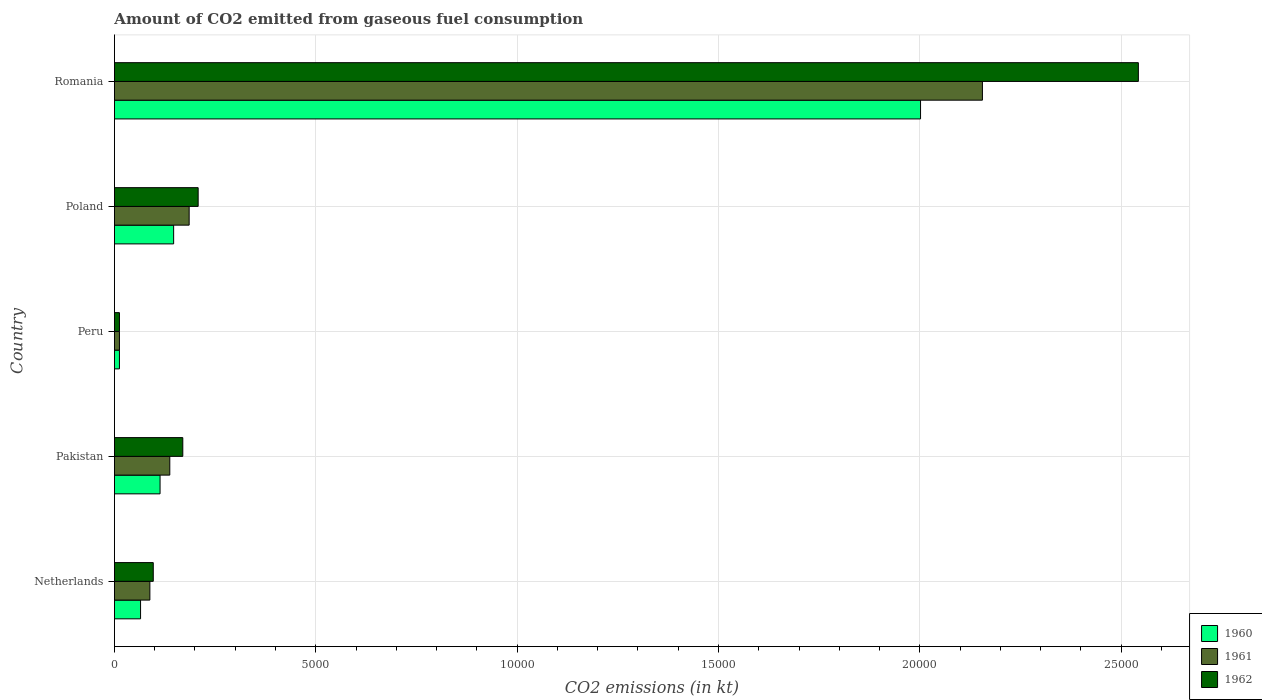How many different coloured bars are there?
Provide a short and direct response. 3. How many bars are there on the 4th tick from the top?
Your response must be concise. 3. What is the amount of CO2 emitted in 1961 in Pakistan?
Ensure brevity in your answer.  1375.12. Across all countries, what is the maximum amount of CO2 emitted in 1961?
Provide a short and direct response. 2.16e+04. Across all countries, what is the minimum amount of CO2 emitted in 1962?
Offer a very short reply. 124.68. In which country was the amount of CO2 emitted in 1962 maximum?
Give a very brief answer. Romania. What is the total amount of CO2 emitted in 1962 in the graph?
Ensure brevity in your answer.  3.03e+04. What is the difference between the amount of CO2 emitted in 1961 in Peru and that in Romania?
Give a very brief answer. -2.14e+04. What is the difference between the amount of CO2 emitted in 1960 in Romania and the amount of CO2 emitted in 1961 in Peru?
Provide a short and direct response. 1.99e+04. What is the average amount of CO2 emitted in 1961 per country?
Provide a succinct answer. 5158. What is the difference between the amount of CO2 emitted in 1962 and amount of CO2 emitted in 1961 in Netherlands?
Offer a very short reply. 84.34. What is the ratio of the amount of CO2 emitted in 1962 in Peru to that in Romania?
Provide a succinct answer. 0. What is the difference between the highest and the second highest amount of CO2 emitted in 1962?
Provide a short and direct response. 2.33e+04. What is the difference between the highest and the lowest amount of CO2 emitted in 1960?
Make the answer very short. 1.99e+04. What does the 1st bar from the top in Poland represents?
Your answer should be compact. 1962. Is it the case that in every country, the sum of the amount of CO2 emitted in 1961 and amount of CO2 emitted in 1962 is greater than the amount of CO2 emitted in 1960?
Offer a very short reply. Yes. How many bars are there?
Your answer should be compact. 15. How many countries are there in the graph?
Ensure brevity in your answer.  5. What is the difference between two consecutive major ticks on the X-axis?
Your response must be concise. 5000. Does the graph contain any zero values?
Your answer should be compact. No. Does the graph contain grids?
Your answer should be very brief. Yes. How many legend labels are there?
Offer a terse response. 3. What is the title of the graph?
Offer a terse response. Amount of CO2 emitted from gaseous fuel consumption. What is the label or title of the X-axis?
Offer a terse response. CO2 emissions (in kt). What is the label or title of the Y-axis?
Offer a very short reply. Country. What is the CO2 emissions (in kt) of 1960 in Netherlands?
Offer a terse response. 649.06. What is the CO2 emissions (in kt) in 1961 in Netherlands?
Provide a short and direct response. 880.08. What is the CO2 emissions (in kt) in 1962 in Netherlands?
Your answer should be very brief. 964.42. What is the CO2 emissions (in kt) in 1960 in Pakistan?
Offer a very short reply. 1133.1. What is the CO2 emissions (in kt) of 1961 in Pakistan?
Provide a short and direct response. 1375.12. What is the CO2 emissions (in kt) in 1962 in Pakistan?
Provide a short and direct response. 1697.82. What is the CO2 emissions (in kt) in 1960 in Peru?
Provide a succinct answer. 124.68. What is the CO2 emissions (in kt) of 1961 in Peru?
Keep it short and to the point. 124.68. What is the CO2 emissions (in kt) of 1962 in Peru?
Provide a succinct answer. 124.68. What is the CO2 emissions (in kt) in 1960 in Poland?
Give a very brief answer. 1470.47. What is the CO2 emissions (in kt) in 1961 in Poland?
Offer a terse response. 1855.5. What is the CO2 emissions (in kt) in 1962 in Poland?
Offer a very short reply. 2079.19. What is the CO2 emissions (in kt) in 1960 in Romania?
Provide a succinct answer. 2.00e+04. What is the CO2 emissions (in kt) in 1961 in Romania?
Offer a very short reply. 2.16e+04. What is the CO2 emissions (in kt) of 1962 in Romania?
Give a very brief answer. 2.54e+04. Across all countries, what is the maximum CO2 emissions (in kt) of 1960?
Give a very brief answer. 2.00e+04. Across all countries, what is the maximum CO2 emissions (in kt) in 1961?
Offer a very short reply. 2.16e+04. Across all countries, what is the maximum CO2 emissions (in kt) of 1962?
Give a very brief answer. 2.54e+04. Across all countries, what is the minimum CO2 emissions (in kt) in 1960?
Provide a succinct answer. 124.68. Across all countries, what is the minimum CO2 emissions (in kt) of 1961?
Make the answer very short. 124.68. Across all countries, what is the minimum CO2 emissions (in kt) in 1962?
Make the answer very short. 124.68. What is the total CO2 emissions (in kt) of 1960 in the graph?
Your answer should be compact. 2.34e+04. What is the total CO2 emissions (in kt) in 1961 in the graph?
Provide a short and direct response. 2.58e+04. What is the total CO2 emissions (in kt) in 1962 in the graph?
Keep it short and to the point. 3.03e+04. What is the difference between the CO2 emissions (in kt) in 1960 in Netherlands and that in Pakistan?
Ensure brevity in your answer.  -484.04. What is the difference between the CO2 emissions (in kt) of 1961 in Netherlands and that in Pakistan?
Provide a short and direct response. -495.05. What is the difference between the CO2 emissions (in kt) in 1962 in Netherlands and that in Pakistan?
Offer a terse response. -733.4. What is the difference between the CO2 emissions (in kt) of 1960 in Netherlands and that in Peru?
Your answer should be compact. 524.38. What is the difference between the CO2 emissions (in kt) of 1961 in Netherlands and that in Peru?
Make the answer very short. 755.4. What is the difference between the CO2 emissions (in kt) of 1962 in Netherlands and that in Peru?
Your response must be concise. 839.74. What is the difference between the CO2 emissions (in kt) of 1960 in Netherlands and that in Poland?
Provide a succinct answer. -821.41. What is the difference between the CO2 emissions (in kt) of 1961 in Netherlands and that in Poland?
Provide a succinct answer. -975.42. What is the difference between the CO2 emissions (in kt) of 1962 in Netherlands and that in Poland?
Keep it short and to the point. -1114.77. What is the difference between the CO2 emissions (in kt) in 1960 in Netherlands and that in Romania?
Provide a succinct answer. -1.94e+04. What is the difference between the CO2 emissions (in kt) in 1961 in Netherlands and that in Romania?
Your response must be concise. -2.07e+04. What is the difference between the CO2 emissions (in kt) of 1962 in Netherlands and that in Romania?
Ensure brevity in your answer.  -2.45e+04. What is the difference between the CO2 emissions (in kt) of 1960 in Pakistan and that in Peru?
Your answer should be compact. 1008.42. What is the difference between the CO2 emissions (in kt) in 1961 in Pakistan and that in Peru?
Make the answer very short. 1250.45. What is the difference between the CO2 emissions (in kt) in 1962 in Pakistan and that in Peru?
Ensure brevity in your answer.  1573.14. What is the difference between the CO2 emissions (in kt) of 1960 in Pakistan and that in Poland?
Give a very brief answer. -337.36. What is the difference between the CO2 emissions (in kt) of 1961 in Pakistan and that in Poland?
Offer a terse response. -480.38. What is the difference between the CO2 emissions (in kt) of 1962 in Pakistan and that in Poland?
Make the answer very short. -381.37. What is the difference between the CO2 emissions (in kt) of 1960 in Pakistan and that in Romania?
Your response must be concise. -1.89e+04. What is the difference between the CO2 emissions (in kt) of 1961 in Pakistan and that in Romania?
Offer a terse response. -2.02e+04. What is the difference between the CO2 emissions (in kt) of 1962 in Pakistan and that in Romania?
Your response must be concise. -2.37e+04. What is the difference between the CO2 emissions (in kt) of 1960 in Peru and that in Poland?
Your answer should be very brief. -1345.79. What is the difference between the CO2 emissions (in kt) in 1961 in Peru and that in Poland?
Your answer should be very brief. -1730.82. What is the difference between the CO2 emissions (in kt) in 1962 in Peru and that in Poland?
Ensure brevity in your answer.  -1954.51. What is the difference between the CO2 emissions (in kt) in 1960 in Peru and that in Romania?
Keep it short and to the point. -1.99e+04. What is the difference between the CO2 emissions (in kt) of 1961 in Peru and that in Romania?
Provide a short and direct response. -2.14e+04. What is the difference between the CO2 emissions (in kt) of 1962 in Peru and that in Romania?
Give a very brief answer. -2.53e+04. What is the difference between the CO2 emissions (in kt) in 1960 in Poland and that in Romania?
Offer a very short reply. -1.85e+04. What is the difference between the CO2 emissions (in kt) in 1961 in Poland and that in Romania?
Provide a short and direct response. -1.97e+04. What is the difference between the CO2 emissions (in kt) in 1962 in Poland and that in Romania?
Your answer should be compact. -2.33e+04. What is the difference between the CO2 emissions (in kt) in 1960 in Netherlands and the CO2 emissions (in kt) in 1961 in Pakistan?
Your answer should be very brief. -726.07. What is the difference between the CO2 emissions (in kt) of 1960 in Netherlands and the CO2 emissions (in kt) of 1962 in Pakistan?
Give a very brief answer. -1048.76. What is the difference between the CO2 emissions (in kt) of 1961 in Netherlands and the CO2 emissions (in kt) of 1962 in Pakistan?
Your answer should be very brief. -817.74. What is the difference between the CO2 emissions (in kt) in 1960 in Netherlands and the CO2 emissions (in kt) in 1961 in Peru?
Keep it short and to the point. 524.38. What is the difference between the CO2 emissions (in kt) in 1960 in Netherlands and the CO2 emissions (in kt) in 1962 in Peru?
Give a very brief answer. 524.38. What is the difference between the CO2 emissions (in kt) of 1961 in Netherlands and the CO2 emissions (in kt) of 1962 in Peru?
Give a very brief answer. 755.4. What is the difference between the CO2 emissions (in kt) of 1960 in Netherlands and the CO2 emissions (in kt) of 1961 in Poland?
Your response must be concise. -1206.44. What is the difference between the CO2 emissions (in kt) of 1960 in Netherlands and the CO2 emissions (in kt) of 1962 in Poland?
Your answer should be compact. -1430.13. What is the difference between the CO2 emissions (in kt) of 1961 in Netherlands and the CO2 emissions (in kt) of 1962 in Poland?
Provide a short and direct response. -1199.11. What is the difference between the CO2 emissions (in kt) of 1960 in Netherlands and the CO2 emissions (in kt) of 1961 in Romania?
Your answer should be very brief. -2.09e+04. What is the difference between the CO2 emissions (in kt) in 1960 in Netherlands and the CO2 emissions (in kt) in 1962 in Romania?
Ensure brevity in your answer.  -2.48e+04. What is the difference between the CO2 emissions (in kt) of 1961 in Netherlands and the CO2 emissions (in kt) of 1962 in Romania?
Keep it short and to the point. -2.45e+04. What is the difference between the CO2 emissions (in kt) of 1960 in Pakistan and the CO2 emissions (in kt) of 1961 in Peru?
Provide a short and direct response. 1008.42. What is the difference between the CO2 emissions (in kt) of 1960 in Pakistan and the CO2 emissions (in kt) of 1962 in Peru?
Offer a very short reply. 1008.42. What is the difference between the CO2 emissions (in kt) of 1961 in Pakistan and the CO2 emissions (in kt) of 1962 in Peru?
Provide a short and direct response. 1250.45. What is the difference between the CO2 emissions (in kt) of 1960 in Pakistan and the CO2 emissions (in kt) of 1961 in Poland?
Your answer should be compact. -722.4. What is the difference between the CO2 emissions (in kt) of 1960 in Pakistan and the CO2 emissions (in kt) of 1962 in Poland?
Offer a very short reply. -946.09. What is the difference between the CO2 emissions (in kt) of 1961 in Pakistan and the CO2 emissions (in kt) of 1962 in Poland?
Provide a succinct answer. -704.06. What is the difference between the CO2 emissions (in kt) of 1960 in Pakistan and the CO2 emissions (in kt) of 1961 in Romania?
Your answer should be compact. -2.04e+04. What is the difference between the CO2 emissions (in kt) of 1960 in Pakistan and the CO2 emissions (in kt) of 1962 in Romania?
Provide a succinct answer. -2.43e+04. What is the difference between the CO2 emissions (in kt) in 1961 in Pakistan and the CO2 emissions (in kt) in 1962 in Romania?
Provide a succinct answer. -2.41e+04. What is the difference between the CO2 emissions (in kt) of 1960 in Peru and the CO2 emissions (in kt) of 1961 in Poland?
Your response must be concise. -1730.82. What is the difference between the CO2 emissions (in kt) of 1960 in Peru and the CO2 emissions (in kt) of 1962 in Poland?
Your answer should be very brief. -1954.51. What is the difference between the CO2 emissions (in kt) in 1961 in Peru and the CO2 emissions (in kt) in 1962 in Poland?
Provide a short and direct response. -1954.51. What is the difference between the CO2 emissions (in kt) of 1960 in Peru and the CO2 emissions (in kt) of 1961 in Romania?
Give a very brief answer. -2.14e+04. What is the difference between the CO2 emissions (in kt) of 1960 in Peru and the CO2 emissions (in kt) of 1962 in Romania?
Offer a very short reply. -2.53e+04. What is the difference between the CO2 emissions (in kt) of 1961 in Peru and the CO2 emissions (in kt) of 1962 in Romania?
Give a very brief answer. -2.53e+04. What is the difference between the CO2 emissions (in kt) of 1960 in Poland and the CO2 emissions (in kt) of 1961 in Romania?
Offer a terse response. -2.01e+04. What is the difference between the CO2 emissions (in kt) in 1960 in Poland and the CO2 emissions (in kt) in 1962 in Romania?
Ensure brevity in your answer.  -2.40e+04. What is the difference between the CO2 emissions (in kt) of 1961 in Poland and the CO2 emissions (in kt) of 1962 in Romania?
Make the answer very short. -2.36e+04. What is the average CO2 emissions (in kt) in 1960 per country?
Provide a succinct answer. 4679.09. What is the average CO2 emissions (in kt) of 1961 per country?
Your response must be concise. 5158. What is the average CO2 emissions (in kt) in 1962 per country?
Your answer should be compact. 6058.62. What is the difference between the CO2 emissions (in kt) in 1960 and CO2 emissions (in kt) in 1961 in Netherlands?
Provide a succinct answer. -231.02. What is the difference between the CO2 emissions (in kt) of 1960 and CO2 emissions (in kt) of 1962 in Netherlands?
Provide a short and direct response. -315.36. What is the difference between the CO2 emissions (in kt) of 1961 and CO2 emissions (in kt) of 1962 in Netherlands?
Provide a succinct answer. -84.34. What is the difference between the CO2 emissions (in kt) of 1960 and CO2 emissions (in kt) of 1961 in Pakistan?
Keep it short and to the point. -242.02. What is the difference between the CO2 emissions (in kt) in 1960 and CO2 emissions (in kt) in 1962 in Pakistan?
Offer a very short reply. -564.72. What is the difference between the CO2 emissions (in kt) in 1961 and CO2 emissions (in kt) in 1962 in Pakistan?
Your response must be concise. -322.7. What is the difference between the CO2 emissions (in kt) in 1960 and CO2 emissions (in kt) in 1961 in Peru?
Your answer should be very brief. 0. What is the difference between the CO2 emissions (in kt) of 1960 and CO2 emissions (in kt) of 1962 in Peru?
Ensure brevity in your answer.  0. What is the difference between the CO2 emissions (in kt) in 1960 and CO2 emissions (in kt) in 1961 in Poland?
Keep it short and to the point. -385.04. What is the difference between the CO2 emissions (in kt) of 1960 and CO2 emissions (in kt) of 1962 in Poland?
Your response must be concise. -608.72. What is the difference between the CO2 emissions (in kt) of 1961 and CO2 emissions (in kt) of 1962 in Poland?
Keep it short and to the point. -223.69. What is the difference between the CO2 emissions (in kt) in 1960 and CO2 emissions (in kt) in 1961 in Romania?
Provide a short and direct response. -1536.47. What is the difference between the CO2 emissions (in kt) in 1960 and CO2 emissions (in kt) in 1962 in Romania?
Your response must be concise. -5408.82. What is the difference between the CO2 emissions (in kt) in 1961 and CO2 emissions (in kt) in 1962 in Romania?
Your answer should be very brief. -3872.35. What is the ratio of the CO2 emissions (in kt) in 1960 in Netherlands to that in Pakistan?
Keep it short and to the point. 0.57. What is the ratio of the CO2 emissions (in kt) in 1961 in Netherlands to that in Pakistan?
Ensure brevity in your answer.  0.64. What is the ratio of the CO2 emissions (in kt) in 1962 in Netherlands to that in Pakistan?
Give a very brief answer. 0.57. What is the ratio of the CO2 emissions (in kt) in 1960 in Netherlands to that in Peru?
Your answer should be compact. 5.21. What is the ratio of the CO2 emissions (in kt) in 1961 in Netherlands to that in Peru?
Your answer should be compact. 7.06. What is the ratio of the CO2 emissions (in kt) of 1962 in Netherlands to that in Peru?
Provide a short and direct response. 7.74. What is the ratio of the CO2 emissions (in kt) in 1960 in Netherlands to that in Poland?
Your answer should be very brief. 0.44. What is the ratio of the CO2 emissions (in kt) of 1961 in Netherlands to that in Poland?
Keep it short and to the point. 0.47. What is the ratio of the CO2 emissions (in kt) of 1962 in Netherlands to that in Poland?
Your answer should be compact. 0.46. What is the ratio of the CO2 emissions (in kt) in 1960 in Netherlands to that in Romania?
Provide a short and direct response. 0.03. What is the ratio of the CO2 emissions (in kt) in 1961 in Netherlands to that in Romania?
Offer a very short reply. 0.04. What is the ratio of the CO2 emissions (in kt) in 1962 in Netherlands to that in Romania?
Your answer should be very brief. 0.04. What is the ratio of the CO2 emissions (in kt) in 1960 in Pakistan to that in Peru?
Keep it short and to the point. 9.09. What is the ratio of the CO2 emissions (in kt) in 1961 in Pakistan to that in Peru?
Your answer should be compact. 11.03. What is the ratio of the CO2 emissions (in kt) of 1962 in Pakistan to that in Peru?
Your response must be concise. 13.62. What is the ratio of the CO2 emissions (in kt) in 1960 in Pakistan to that in Poland?
Your answer should be very brief. 0.77. What is the ratio of the CO2 emissions (in kt) in 1961 in Pakistan to that in Poland?
Your response must be concise. 0.74. What is the ratio of the CO2 emissions (in kt) of 1962 in Pakistan to that in Poland?
Offer a very short reply. 0.82. What is the ratio of the CO2 emissions (in kt) of 1960 in Pakistan to that in Romania?
Your response must be concise. 0.06. What is the ratio of the CO2 emissions (in kt) in 1961 in Pakistan to that in Romania?
Offer a very short reply. 0.06. What is the ratio of the CO2 emissions (in kt) in 1962 in Pakistan to that in Romania?
Offer a very short reply. 0.07. What is the ratio of the CO2 emissions (in kt) of 1960 in Peru to that in Poland?
Your answer should be compact. 0.08. What is the ratio of the CO2 emissions (in kt) of 1961 in Peru to that in Poland?
Your response must be concise. 0.07. What is the ratio of the CO2 emissions (in kt) of 1962 in Peru to that in Poland?
Make the answer very short. 0.06. What is the ratio of the CO2 emissions (in kt) in 1960 in Peru to that in Romania?
Provide a succinct answer. 0.01. What is the ratio of the CO2 emissions (in kt) in 1961 in Peru to that in Romania?
Provide a succinct answer. 0.01. What is the ratio of the CO2 emissions (in kt) in 1962 in Peru to that in Romania?
Provide a short and direct response. 0. What is the ratio of the CO2 emissions (in kt) in 1960 in Poland to that in Romania?
Your answer should be compact. 0.07. What is the ratio of the CO2 emissions (in kt) in 1961 in Poland to that in Romania?
Make the answer very short. 0.09. What is the ratio of the CO2 emissions (in kt) in 1962 in Poland to that in Romania?
Provide a succinct answer. 0.08. What is the difference between the highest and the second highest CO2 emissions (in kt) of 1960?
Make the answer very short. 1.85e+04. What is the difference between the highest and the second highest CO2 emissions (in kt) in 1961?
Ensure brevity in your answer.  1.97e+04. What is the difference between the highest and the second highest CO2 emissions (in kt) in 1962?
Your answer should be compact. 2.33e+04. What is the difference between the highest and the lowest CO2 emissions (in kt) of 1960?
Make the answer very short. 1.99e+04. What is the difference between the highest and the lowest CO2 emissions (in kt) of 1961?
Offer a very short reply. 2.14e+04. What is the difference between the highest and the lowest CO2 emissions (in kt) in 1962?
Ensure brevity in your answer.  2.53e+04. 